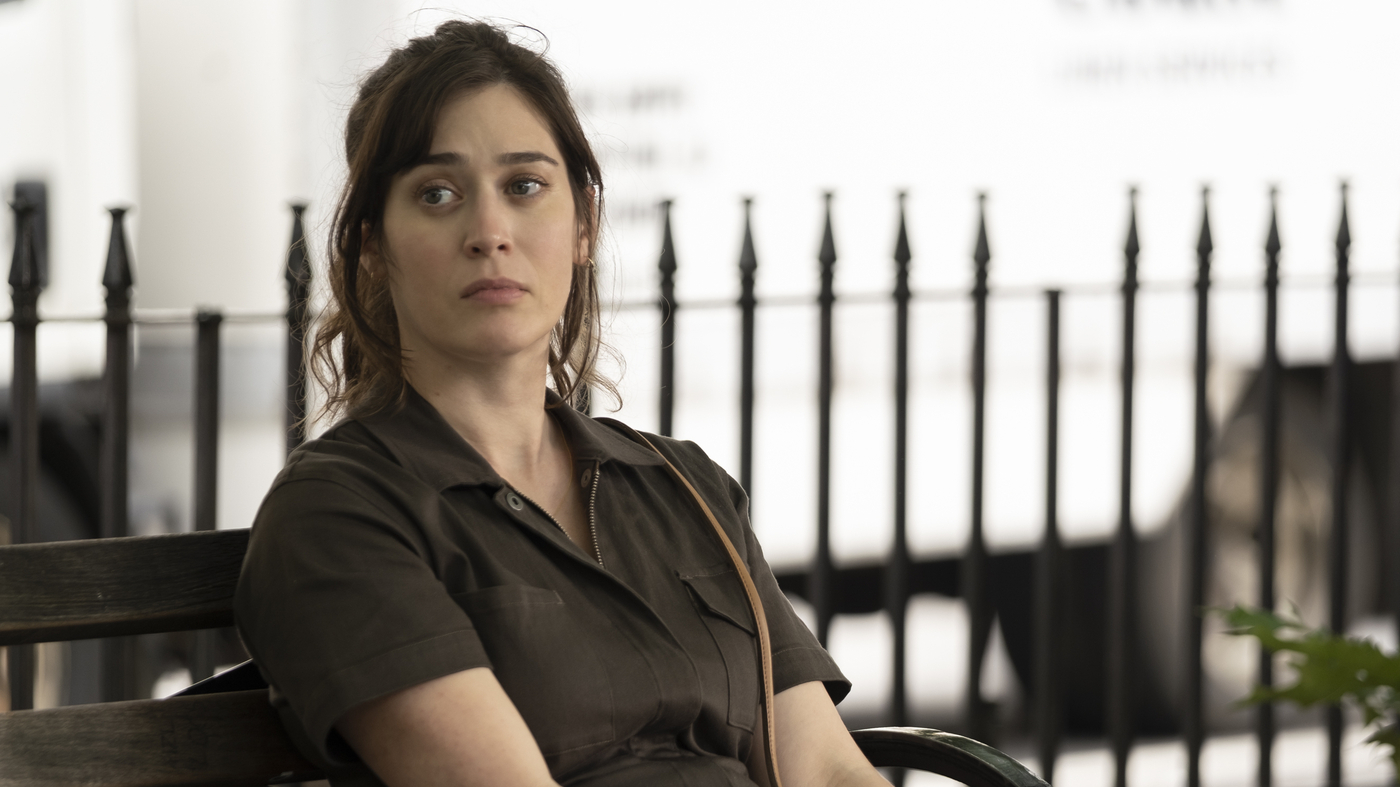What do you see happening in this image? The image showcases a woman seated alone on a dark wooden bench, reflecting or possibly waiting for someone. She is dressed in a casual brown button-up dress, and she gazes to the side with a look of contemplation on her face. The surroundings include a white building with black railings and a touch of greenery, suggesting a peaceful, possibly urban environment. Her relaxed posture and distant gaze add to the tranquil yet solitary mood of the scene. 